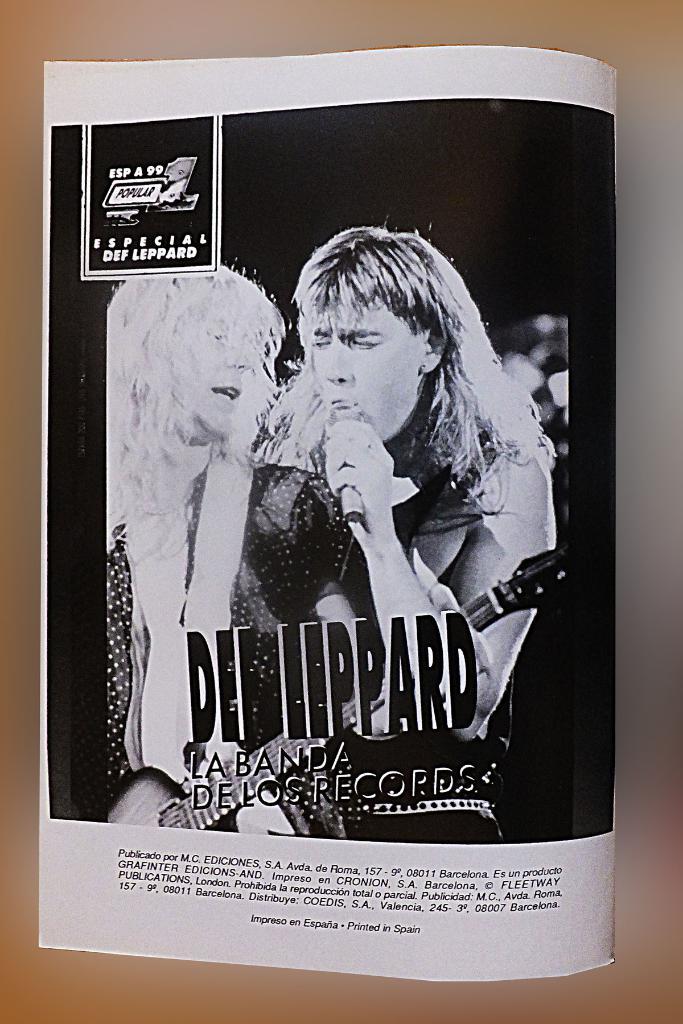What is the name of the band in the poster?
Provide a short and direct response. Def leppard. 